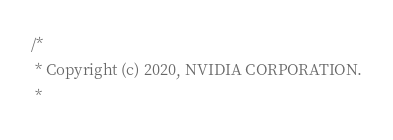<code> <loc_0><loc_0><loc_500><loc_500><_C++_>/*
 * Copyright (c) 2020, NVIDIA CORPORATION.
 *</code> 